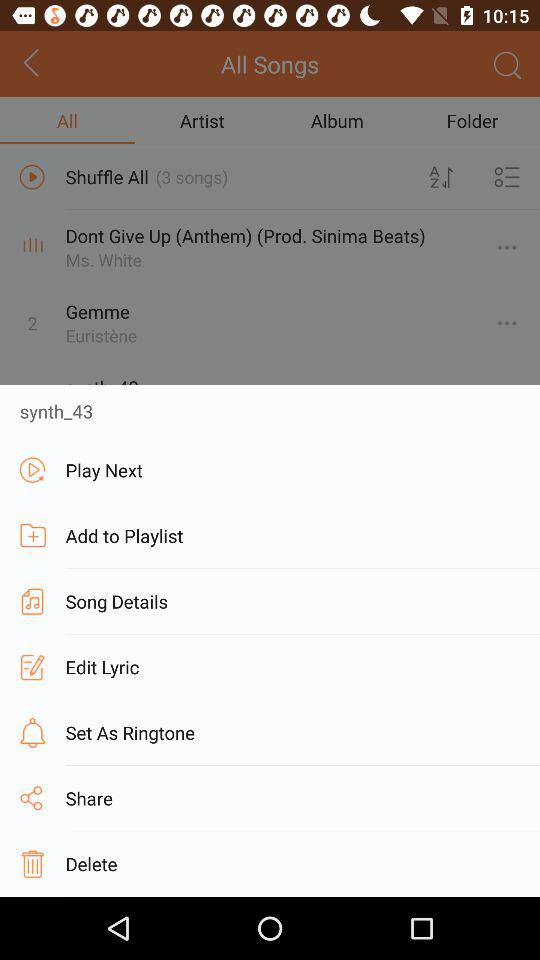Which tab am I on? You are on the "All" tab. 